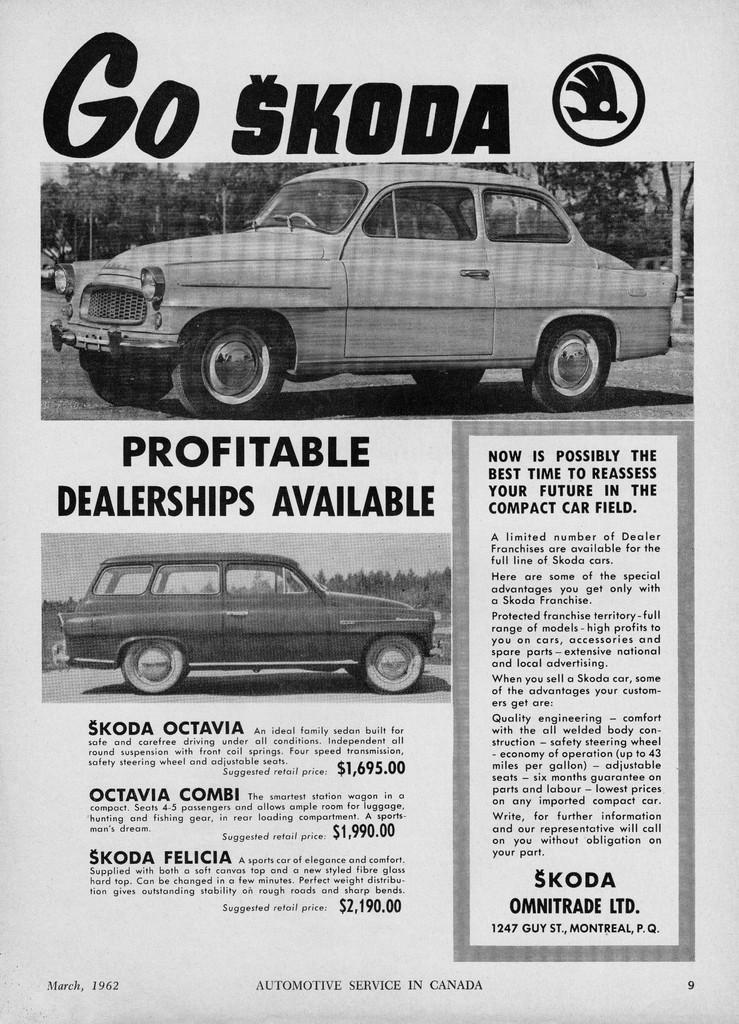What can be found on the image in terms of written content? There is text written on the image. What type of objects are depicted in the images on the image? There are images of cars and trees on the image. Can you describe the eye of the creator in the image? There is no eye or creator depicted in the image; it only contains text and images of cars and trees. 